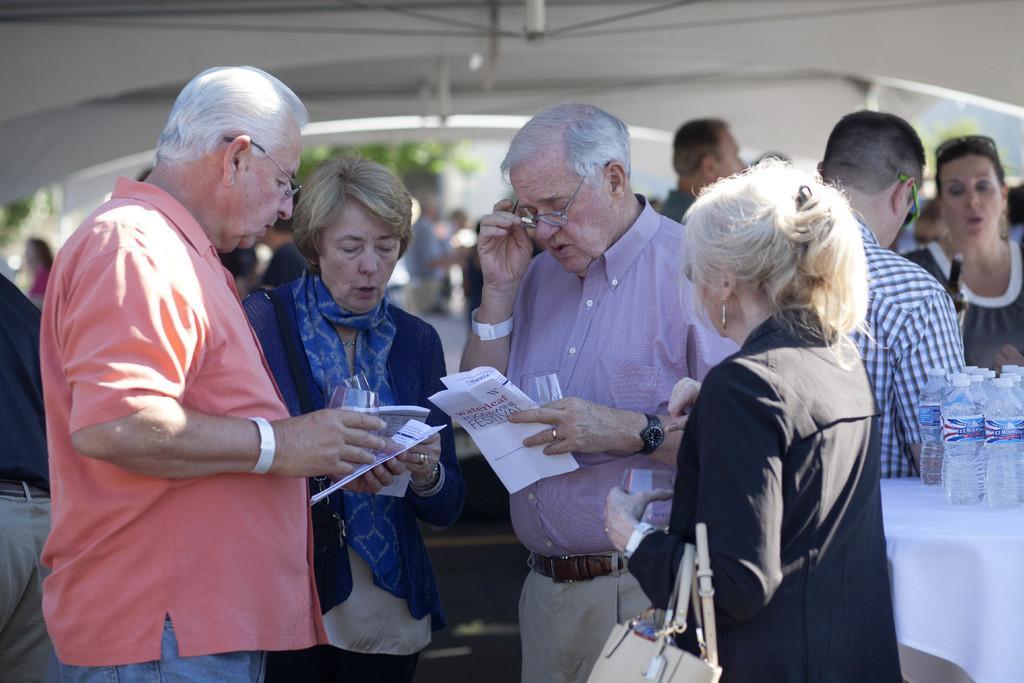How would you summarize this image in a sentence or two? In this image there are many people standing. In the foreground there are four people standing. They are holding wine glasses and papers in their hands. To the right there is a table. There is a cloth spread on the table. On the table there are water bottles. At the top there is the ceiling. In the background there are leaves of plants and trees. 